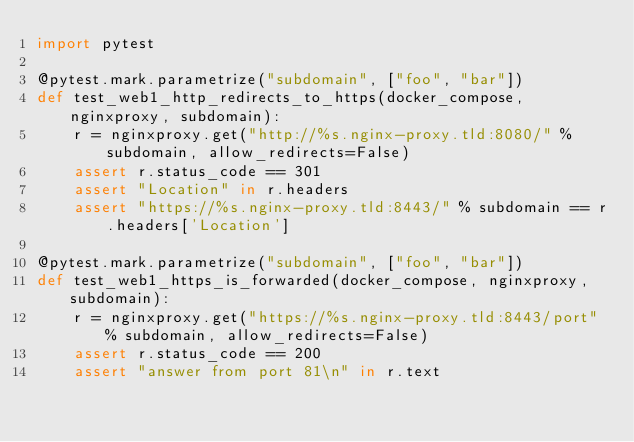<code> <loc_0><loc_0><loc_500><loc_500><_Python_>import pytest

@pytest.mark.parametrize("subdomain", ["foo", "bar"])
def test_web1_http_redirects_to_https(docker_compose, nginxproxy, subdomain):
    r = nginxproxy.get("http://%s.nginx-proxy.tld:8080/" % subdomain, allow_redirects=False)
    assert r.status_code == 301
    assert "Location" in r.headers
    assert "https://%s.nginx-proxy.tld:8443/" % subdomain == r.headers['Location']

@pytest.mark.parametrize("subdomain", ["foo", "bar"])
def test_web1_https_is_forwarded(docker_compose, nginxproxy, subdomain):
    r = nginxproxy.get("https://%s.nginx-proxy.tld:8443/port" % subdomain, allow_redirects=False)
    assert r.status_code == 200
    assert "answer from port 81\n" in r.text</code> 